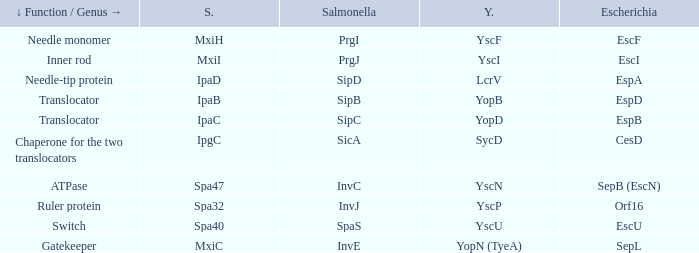Tell me the shigella and yscn Spa47. 